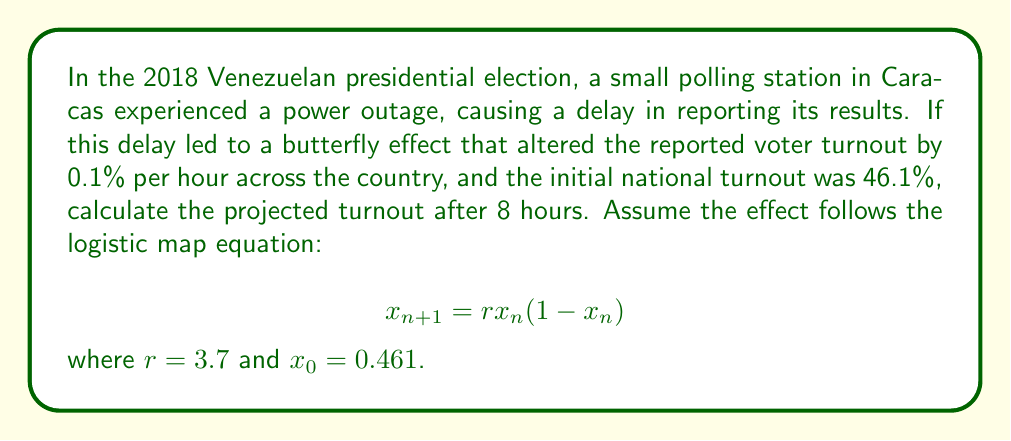Can you solve this math problem? To solve this problem, we need to apply the logistic map equation iteratively for 8 hours:

1. Start with $x_0 = 0.461$ (initial turnout)
2. Use $r = 3.7$ (growth rate)
3. Apply the equation for 8 iterations:

$$x_1 = 3.7 \cdot 0.461 \cdot (1 - 0.461) = 0.916813$$
$$x_2 = 3.7 \cdot 0.916813 \cdot (1 - 0.916813) = 0.282925$$
$$x_3 = 3.7 \cdot 0.282925 \cdot (1 - 0.282925) = 0.751143$$
$$x_4 = 3.7 \cdot 0.751143 \cdot (1 - 0.751143) = 0.691577$$
$$x_5 = 3.7 \cdot 0.691577 \cdot (1 - 0.691577) = 0.788913$$
$$x_6 = 3.7 \cdot 0.788913 \cdot (1 - 0.788913) = 0.616266$$
$$x_7 = 3.7 \cdot 0.616266 \cdot (1 - 0.616266) = 0.874214$$
$$x_8 = 3.7 \cdot 0.874214 \cdot (1 - 0.874214) = 0.407377$$

The final projected turnout after 8 hours is approximately 0.407377 or 40.74%.
Answer: 40.74% 